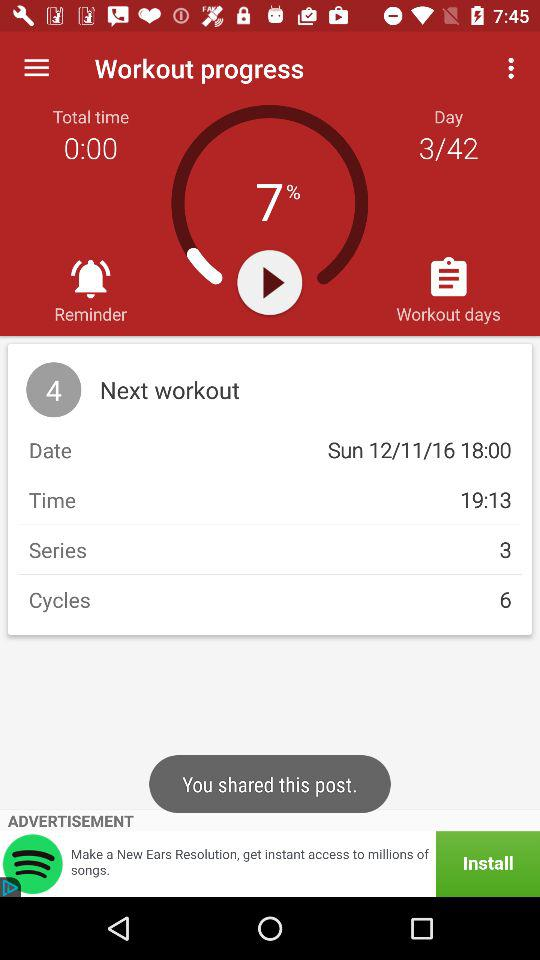How many series are there for the next workout? There are 3 series. 